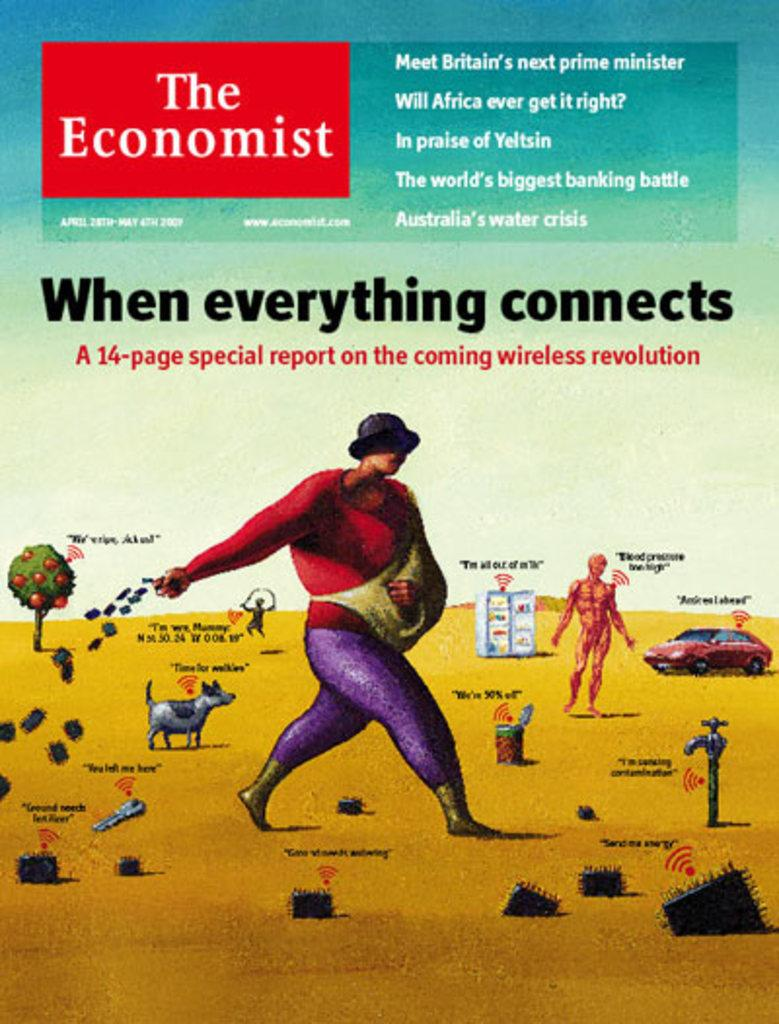<image>
Relay a brief, clear account of the picture shown. A book titled When Everything Connects. about the wireless revolution. 